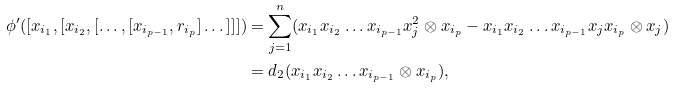Convert formula to latex. <formula><loc_0><loc_0><loc_500><loc_500>\phi ^ { \prime } ( [ x _ { i _ { 1 } } , [ x _ { i _ { 2 } } , [ \dots , [ x _ { i _ { p - 1 } } , r _ { i _ { p } } ] \dots ] ] ] ) & = \sum _ { j = 1 } ^ { n } ( x _ { i _ { 1 } } x _ { i _ { 2 } } \dots x _ { i _ { p - 1 } } x _ { j } ^ { 2 } \otimes x _ { i _ { p } } - x _ { i _ { 1 } } x _ { i _ { 2 } } \dots x _ { i _ { p - 1 } } x _ { j } x _ { i _ { p } } \otimes x _ { j } ) \\ & = d _ { 2 } ( x _ { i _ { 1 } } x _ { i _ { 2 } } \dots x _ { i _ { p - 1 } } \otimes x _ { i _ { p } } ) ,</formula> 